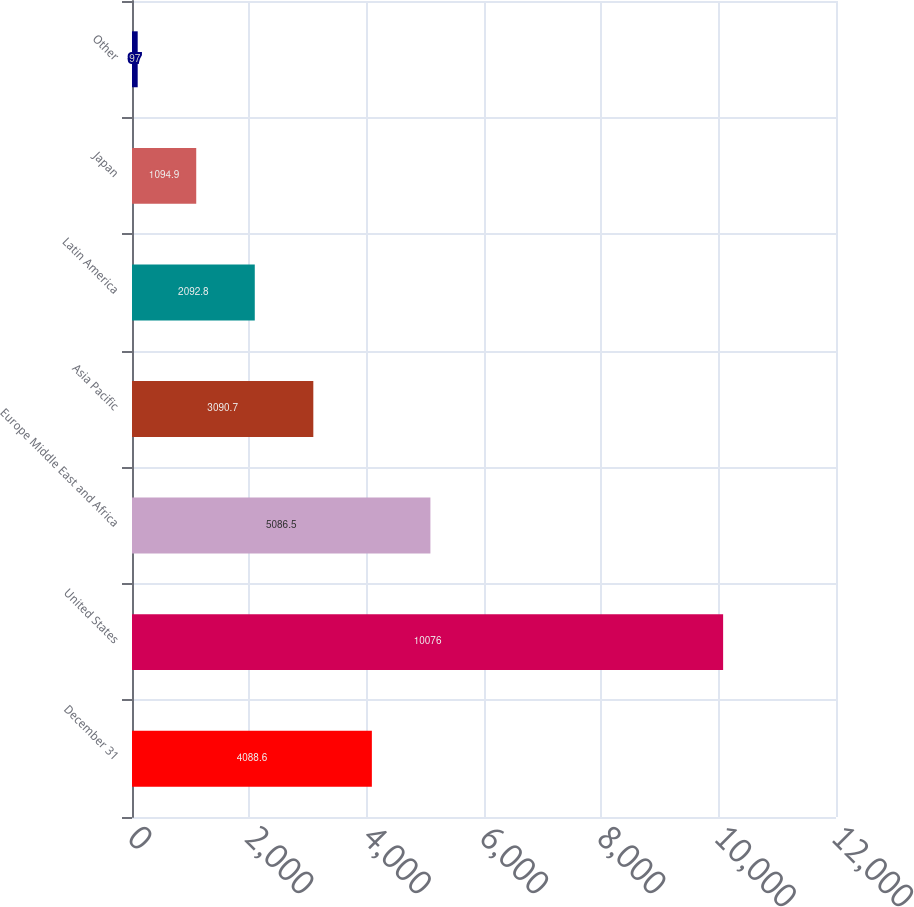<chart> <loc_0><loc_0><loc_500><loc_500><bar_chart><fcel>December 31<fcel>United States<fcel>Europe Middle East and Africa<fcel>Asia Pacific<fcel>Latin America<fcel>Japan<fcel>Other<nl><fcel>4088.6<fcel>10076<fcel>5086.5<fcel>3090.7<fcel>2092.8<fcel>1094.9<fcel>97<nl></chart> 